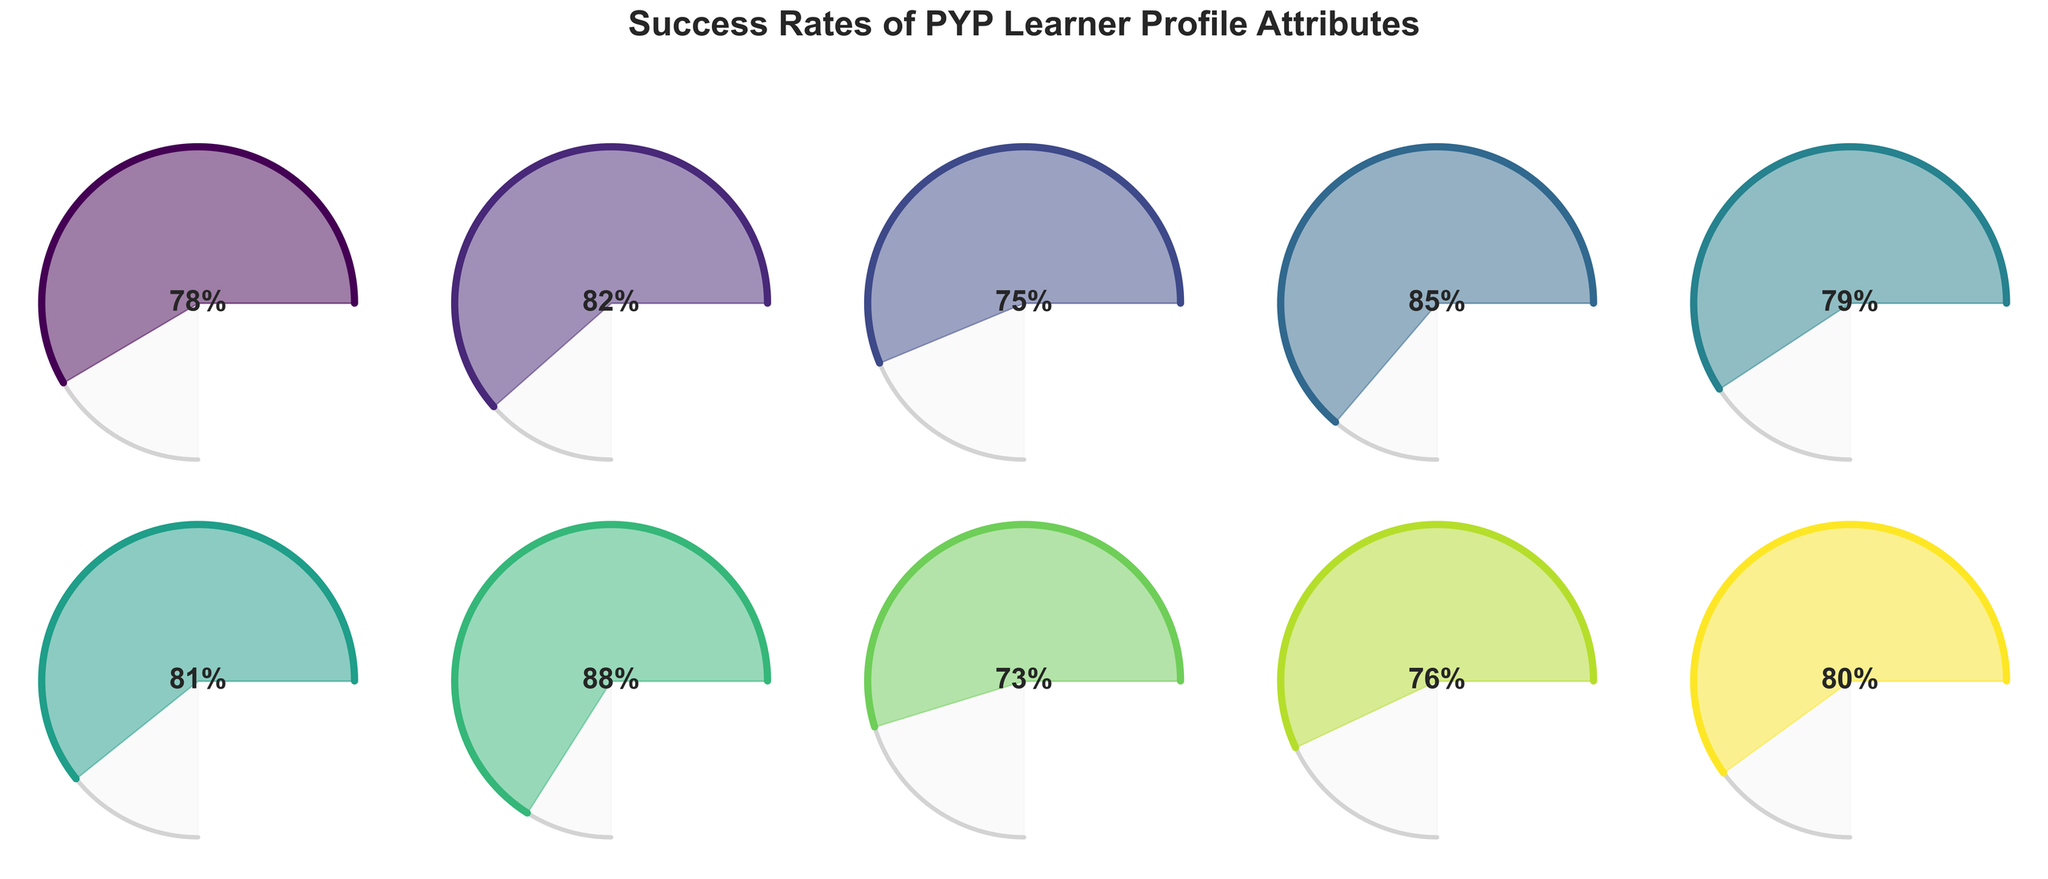What is the success rate for the attribute "Caring"? The "Caring" gauge chart shows the rate in the center, which is 88%.
Answer: 88% Which learner profile attribute has the lowest success rate? By visually comparing each gauge chart, the "Risk-takers" attribute has the lowest success rate at 73%.
Answer: Risk-takers What is the average success rate across all attributes? Sum all success rates (78+82+75+85+79+81+88+73+76+80) to get 797. Divide by the number of attributes (10) to find the average: 797/10 = 79.7%.
Answer: 79.7% How does the success rate of "Communicators" compare to "Reflective"? The success rate of "Communicators" is 85%, which is higher than "Reflective" at 80%.
Answer: "Communicators" is higher than "Reflective" What is the total number of attributes with a success rate of 80% or above? The attributes with success rates of 80% or above are Knowledgeable (82%), Communicators (85%), Open-minded (81%), Caring (88%), and Reflective (80%), totaling 5 attributes.
Answer: 5 Which attributes have success rates within 3 percentage points of each other? Identify attributes by comparing rates: "Knowledgeable" (82%) and "Open-minded" (81%) have a difference of 1 percentage point; "Thinkers" (75%) and "Risk-takers" (73%) have a difference of 2 percentage points; "Balanced" (76%) and "Thinkers" (75%) have a difference of 1 percentage point; "Reflective" (80%) and "Principled" (79%) have a difference of 1 percentage point.
Answer: Knowledgeable & Open-minded, Thinkers & Risk-takers, Balanced & Thinkers, Reflective & Principled What is the difference between the highest and lowest success rates? The highest success rate is "Caring" at 88%, and the lowest is "Risk-takers" at 73%. The difference is 88 - 73 = 15%.
Answer: 15% What percentage of attributes have a success rate higher than 75%? There are 8 attributes with success rates higher than 75% out of a total of 10 attributes, which calculates to 80%.
Answer: 80% Are there any attributes with the same success rate? By examining each gauge chart, no two attributes share the same exact success rate.
Answer: No 